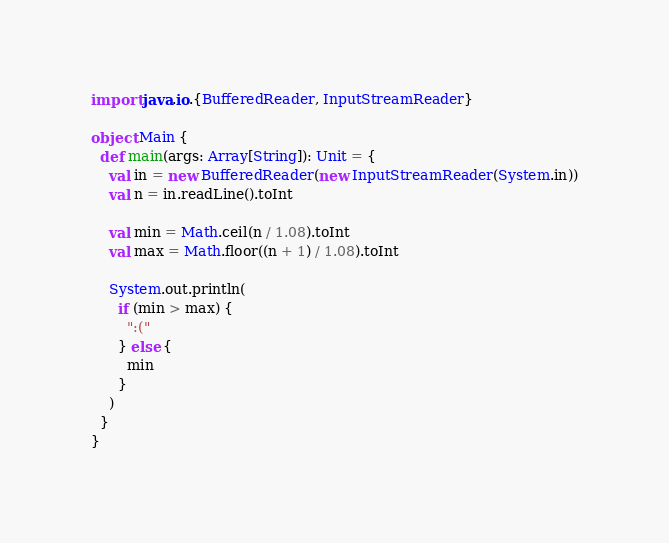Convert code to text. <code><loc_0><loc_0><loc_500><loc_500><_Scala_>import java.io.{BufferedReader, InputStreamReader}

object Main {
  def main(args: Array[String]): Unit = {
    val in = new BufferedReader(new InputStreamReader(System.in))
    val n = in.readLine().toInt

    val min = Math.ceil(n / 1.08).toInt
    val max = Math.floor((n + 1) / 1.08).toInt

    System.out.println(
      if (min > max) {
        ":("
      } else {
        min
      }
    )
  }
}
</code> 